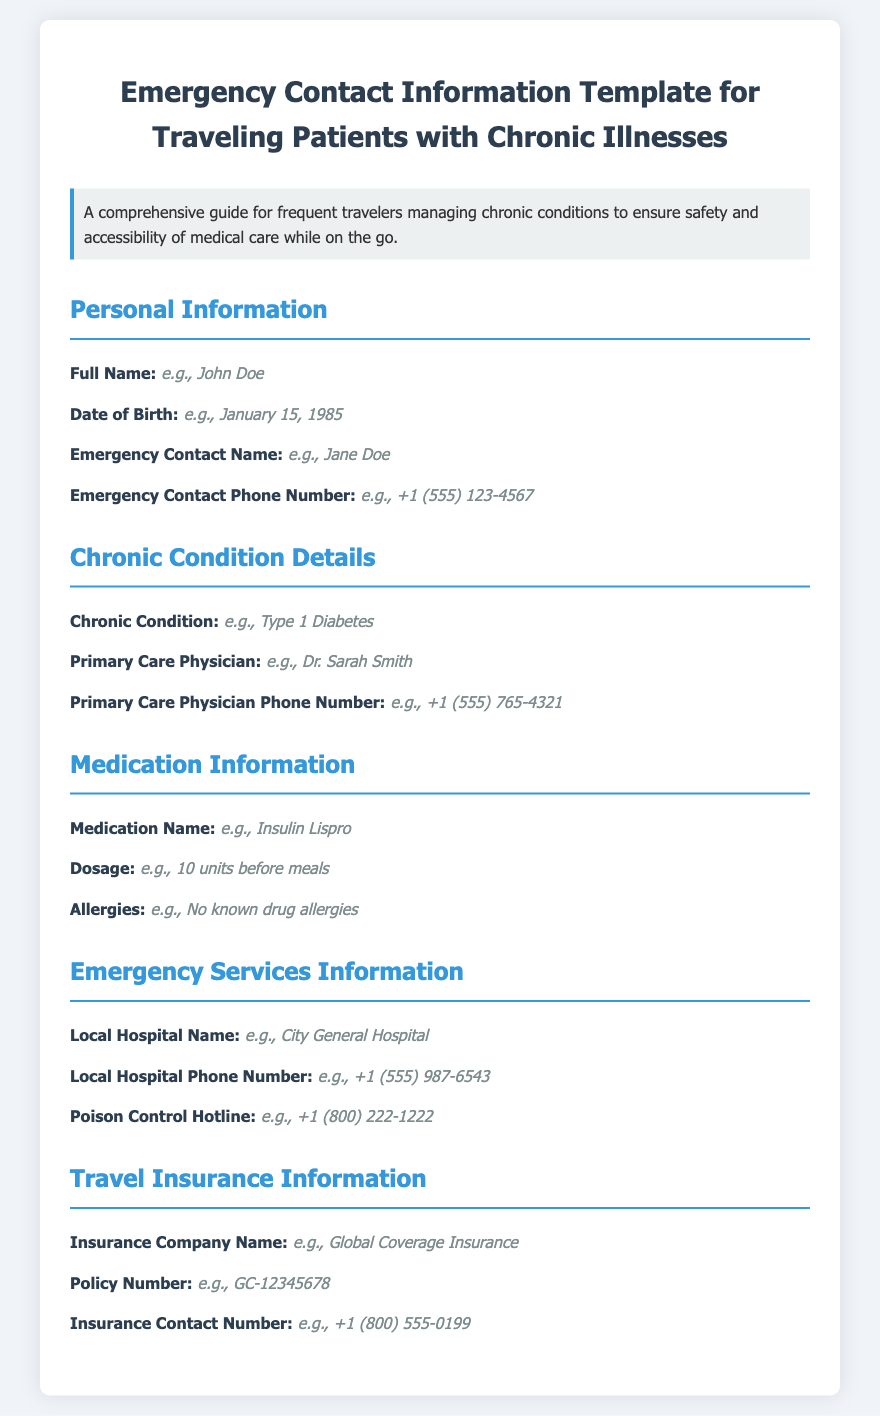What is the title of the document? The title appears at the top of the document, identifying its purpose for emergency contact information for a specific group.
Answer: Emergency Contact Information Template for Traveling Patients with Chronic Illnesses What is the example emergency contact phone number provided? The provided example in the document serves as a placeholder for users to understand the format of the phone number they should enter.
Answer: +1 (555) 123-4567 Who is the primary care physician listed in the example? The document includes an example to illustrate what kind of information should be filled in for the primary care physician.
Answer: Dr. Sarah Smith What medication name is given in the sample information? The sample medication name represents an example of what patients might need to include for their condition management.
Answer: Insulin Lispro What is the poison control hotline number provided? This information is relevant for patients and is presented in the emergency services section for quick access in case of emergencies.
Answer: +1 (800) 222-1222 How many sections are in the document? The number of sections can be counted in the document based on the headers indicating different categories of information.
Answer: Five What chronic condition is used in the example? This information serves as an indication of what type of chronic conditions travelers need to document for safety during their travels.
Answer: Type 1 Diabetes What is the local hospital name provided in the document? The example provides a fictional name for clarity on what information to supply regarding local healthcare facilities.
Answer: City General Hospital What should you include for travel insurance contact information? The document suggests including specific details about insurance to ensure accessibility in emergencies while traveling.
Answer: Insurance Company Name, Policy Number, Insurance Contact Number 